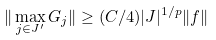Convert formula to latex. <formula><loc_0><loc_0><loc_500><loc_500>\| \max _ { j \in J ^ { \prime } } G _ { j } \| \geq ( C / 4 ) | J | ^ { 1 / p } \| f \|</formula> 